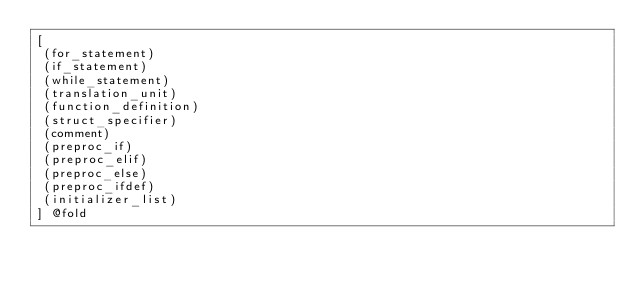<code> <loc_0><loc_0><loc_500><loc_500><_Scheme_>[
 (for_statement)
 (if_statement)
 (while_statement)
 (translation_unit)
 (function_definition)
 (struct_specifier)
 (comment)
 (preproc_if)
 (preproc_elif)
 (preproc_else)
 (preproc_ifdef)
 (initializer_list)
] @fold

</code> 